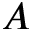<formula> <loc_0><loc_0><loc_500><loc_500>A</formula> 